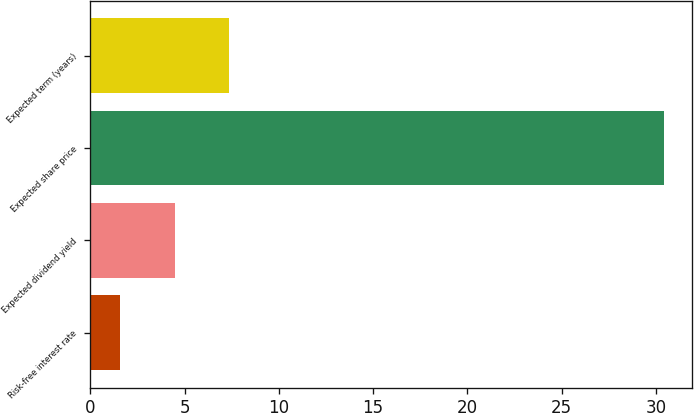<chart> <loc_0><loc_0><loc_500><loc_500><bar_chart><fcel>Risk-free interest rate<fcel>Expected dividend yield<fcel>Expected share price<fcel>Expected term (years)<nl><fcel>1.6<fcel>4.48<fcel>30.4<fcel>7.36<nl></chart> 